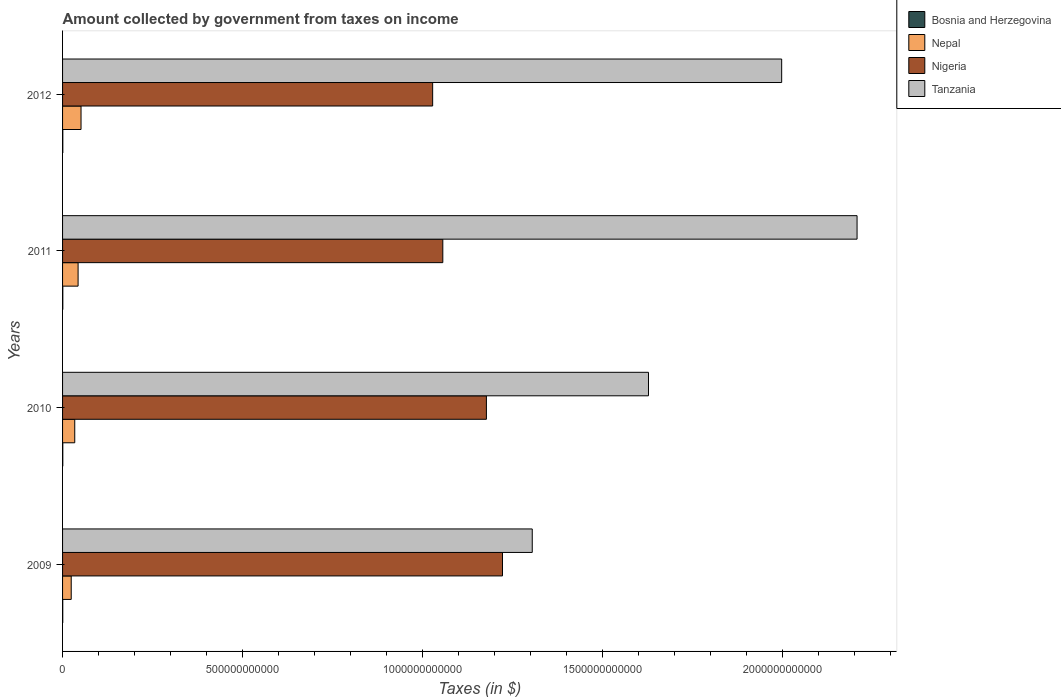Are the number of bars on each tick of the Y-axis equal?
Your answer should be very brief. Yes. How many bars are there on the 4th tick from the top?
Give a very brief answer. 4. In how many cases, is the number of bars for a given year not equal to the number of legend labels?
Offer a terse response. 0. What is the amount collected by government from taxes on income in Nigeria in 2012?
Provide a succinct answer. 1.03e+12. Across all years, what is the maximum amount collected by government from taxes on income in Nigeria?
Keep it short and to the point. 1.22e+12. Across all years, what is the minimum amount collected by government from taxes on income in Bosnia and Herzegovina?
Give a very brief answer. 4.93e+08. What is the total amount collected by government from taxes on income in Nigeria in the graph?
Your answer should be very brief. 4.48e+12. What is the difference between the amount collected by government from taxes on income in Bosnia and Herzegovina in 2010 and that in 2011?
Provide a succinct answer. -5.28e+07. What is the difference between the amount collected by government from taxes on income in Tanzania in 2010 and the amount collected by government from taxes on income in Nepal in 2009?
Offer a terse response. 1.60e+12. What is the average amount collected by government from taxes on income in Tanzania per year?
Offer a very short reply. 1.78e+12. In the year 2011, what is the difference between the amount collected by government from taxes on income in Bosnia and Herzegovina and amount collected by government from taxes on income in Nigeria?
Your response must be concise. -1.06e+12. What is the ratio of the amount collected by government from taxes on income in Tanzania in 2011 to that in 2012?
Give a very brief answer. 1.1. Is the difference between the amount collected by government from taxes on income in Bosnia and Herzegovina in 2010 and 2011 greater than the difference between the amount collected by government from taxes on income in Nigeria in 2010 and 2011?
Provide a short and direct response. No. What is the difference between the highest and the second highest amount collected by government from taxes on income in Nigeria?
Offer a very short reply. 4.47e+1. What is the difference between the highest and the lowest amount collected by government from taxes on income in Bosnia and Herzegovina?
Make the answer very short. 2.05e+08. What does the 2nd bar from the top in 2011 represents?
Provide a short and direct response. Nigeria. What does the 2nd bar from the bottom in 2012 represents?
Make the answer very short. Nepal. What is the difference between two consecutive major ticks on the X-axis?
Make the answer very short. 5.00e+11. How are the legend labels stacked?
Offer a terse response. Vertical. What is the title of the graph?
Provide a short and direct response. Amount collected by government from taxes on income. What is the label or title of the X-axis?
Your answer should be very brief. Taxes (in $). What is the label or title of the Y-axis?
Give a very brief answer. Years. What is the Taxes (in $) of Bosnia and Herzegovina in 2009?
Provide a succinct answer. 4.93e+08. What is the Taxes (in $) of Nepal in 2009?
Your response must be concise. 2.41e+1. What is the Taxes (in $) in Nigeria in 2009?
Your answer should be compact. 1.22e+12. What is the Taxes (in $) in Tanzania in 2009?
Your answer should be compact. 1.30e+12. What is the Taxes (in $) of Bosnia and Herzegovina in 2010?
Offer a very short reply. 6.25e+08. What is the Taxes (in $) in Nepal in 2010?
Provide a succinct answer. 3.38e+1. What is the Taxes (in $) in Nigeria in 2010?
Your answer should be very brief. 1.18e+12. What is the Taxes (in $) of Tanzania in 2010?
Your answer should be very brief. 1.63e+12. What is the Taxes (in $) in Bosnia and Herzegovina in 2011?
Keep it short and to the point. 6.78e+08. What is the Taxes (in $) of Nepal in 2011?
Keep it short and to the point. 4.31e+1. What is the Taxes (in $) of Nigeria in 2011?
Keep it short and to the point. 1.06e+12. What is the Taxes (in $) of Tanzania in 2011?
Provide a succinct answer. 2.21e+12. What is the Taxes (in $) in Bosnia and Herzegovina in 2012?
Make the answer very short. 6.98e+08. What is the Taxes (in $) in Nepal in 2012?
Offer a very short reply. 5.13e+1. What is the Taxes (in $) in Nigeria in 2012?
Provide a succinct answer. 1.03e+12. What is the Taxes (in $) in Tanzania in 2012?
Your answer should be compact. 2.00e+12. Across all years, what is the maximum Taxes (in $) in Bosnia and Herzegovina?
Provide a succinct answer. 6.98e+08. Across all years, what is the maximum Taxes (in $) in Nepal?
Offer a terse response. 5.13e+1. Across all years, what is the maximum Taxes (in $) in Nigeria?
Provide a short and direct response. 1.22e+12. Across all years, what is the maximum Taxes (in $) of Tanzania?
Your response must be concise. 2.21e+12. Across all years, what is the minimum Taxes (in $) of Bosnia and Herzegovina?
Offer a terse response. 4.93e+08. Across all years, what is the minimum Taxes (in $) of Nepal?
Your answer should be very brief. 2.41e+1. Across all years, what is the minimum Taxes (in $) in Nigeria?
Ensure brevity in your answer.  1.03e+12. Across all years, what is the minimum Taxes (in $) in Tanzania?
Provide a succinct answer. 1.30e+12. What is the total Taxes (in $) in Bosnia and Herzegovina in the graph?
Your answer should be very brief. 2.50e+09. What is the total Taxes (in $) in Nepal in the graph?
Provide a succinct answer. 1.52e+11. What is the total Taxes (in $) of Nigeria in the graph?
Keep it short and to the point. 4.48e+12. What is the total Taxes (in $) of Tanzania in the graph?
Your response must be concise. 7.14e+12. What is the difference between the Taxes (in $) of Bosnia and Herzegovina in 2009 and that in 2010?
Make the answer very short. -1.32e+08. What is the difference between the Taxes (in $) of Nepal in 2009 and that in 2010?
Offer a very short reply. -9.77e+09. What is the difference between the Taxes (in $) in Nigeria in 2009 and that in 2010?
Offer a terse response. 4.47e+1. What is the difference between the Taxes (in $) of Tanzania in 2009 and that in 2010?
Ensure brevity in your answer.  -3.23e+11. What is the difference between the Taxes (in $) of Bosnia and Herzegovina in 2009 and that in 2011?
Your answer should be compact. -1.85e+08. What is the difference between the Taxes (in $) in Nepal in 2009 and that in 2011?
Provide a succinct answer. -1.91e+1. What is the difference between the Taxes (in $) of Nigeria in 2009 and that in 2011?
Your answer should be very brief. 1.66e+11. What is the difference between the Taxes (in $) of Tanzania in 2009 and that in 2011?
Your response must be concise. -9.02e+11. What is the difference between the Taxes (in $) of Bosnia and Herzegovina in 2009 and that in 2012?
Ensure brevity in your answer.  -2.05e+08. What is the difference between the Taxes (in $) of Nepal in 2009 and that in 2012?
Make the answer very short. -2.73e+1. What is the difference between the Taxes (in $) in Nigeria in 2009 and that in 2012?
Offer a very short reply. 1.94e+11. What is the difference between the Taxes (in $) in Tanzania in 2009 and that in 2012?
Offer a terse response. -6.93e+11. What is the difference between the Taxes (in $) in Bosnia and Herzegovina in 2010 and that in 2011?
Your response must be concise. -5.28e+07. What is the difference between the Taxes (in $) of Nepal in 2010 and that in 2011?
Your response must be concise. -9.30e+09. What is the difference between the Taxes (in $) of Nigeria in 2010 and that in 2011?
Make the answer very short. 1.21e+11. What is the difference between the Taxes (in $) in Tanzania in 2010 and that in 2011?
Give a very brief answer. -5.79e+11. What is the difference between the Taxes (in $) of Bosnia and Herzegovina in 2010 and that in 2012?
Your answer should be compact. -7.31e+07. What is the difference between the Taxes (in $) in Nepal in 2010 and that in 2012?
Ensure brevity in your answer.  -1.75e+1. What is the difference between the Taxes (in $) of Nigeria in 2010 and that in 2012?
Provide a succinct answer. 1.49e+11. What is the difference between the Taxes (in $) in Tanzania in 2010 and that in 2012?
Give a very brief answer. -3.70e+11. What is the difference between the Taxes (in $) in Bosnia and Herzegovina in 2011 and that in 2012?
Provide a short and direct response. -2.03e+07. What is the difference between the Taxes (in $) of Nepal in 2011 and that in 2012?
Keep it short and to the point. -8.18e+09. What is the difference between the Taxes (in $) in Nigeria in 2011 and that in 2012?
Offer a terse response. 2.82e+1. What is the difference between the Taxes (in $) in Tanzania in 2011 and that in 2012?
Offer a very short reply. 2.09e+11. What is the difference between the Taxes (in $) of Bosnia and Herzegovina in 2009 and the Taxes (in $) of Nepal in 2010?
Provide a short and direct response. -3.33e+1. What is the difference between the Taxes (in $) of Bosnia and Herzegovina in 2009 and the Taxes (in $) of Nigeria in 2010?
Give a very brief answer. -1.18e+12. What is the difference between the Taxes (in $) in Bosnia and Herzegovina in 2009 and the Taxes (in $) in Tanzania in 2010?
Ensure brevity in your answer.  -1.63e+12. What is the difference between the Taxes (in $) of Nepal in 2009 and the Taxes (in $) of Nigeria in 2010?
Offer a very short reply. -1.15e+12. What is the difference between the Taxes (in $) in Nepal in 2009 and the Taxes (in $) in Tanzania in 2010?
Keep it short and to the point. -1.60e+12. What is the difference between the Taxes (in $) of Nigeria in 2009 and the Taxes (in $) of Tanzania in 2010?
Your answer should be very brief. -4.05e+11. What is the difference between the Taxes (in $) of Bosnia and Herzegovina in 2009 and the Taxes (in $) of Nepal in 2011?
Provide a succinct answer. -4.26e+1. What is the difference between the Taxes (in $) of Bosnia and Herzegovina in 2009 and the Taxes (in $) of Nigeria in 2011?
Your answer should be compact. -1.06e+12. What is the difference between the Taxes (in $) in Bosnia and Herzegovina in 2009 and the Taxes (in $) in Tanzania in 2011?
Provide a short and direct response. -2.21e+12. What is the difference between the Taxes (in $) in Nepal in 2009 and the Taxes (in $) in Nigeria in 2011?
Keep it short and to the point. -1.03e+12. What is the difference between the Taxes (in $) of Nepal in 2009 and the Taxes (in $) of Tanzania in 2011?
Provide a succinct answer. -2.18e+12. What is the difference between the Taxes (in $) of Nigeria in 2009 and the Taxes (in $) of Tanzania in 2011?
Make the answer very short. -9.85e+11. What is the difference between the Taxes (in $) of Bosnia and Herzegovina in 2009 and the Taxes (in $) of Nepal in 2012?
Keep it short and to the point. -5.08e+1. What is the difference between the Taxes (in $) of Bosnia and Herzegovina in 2009 and the Taxes (in $) of Nigeria in 2012?
Your answer should be very brief. -1.03e+12. What is the difference between the Taxes (in $) of Bosnia and Herzegovina in 2009 and the Taxes (in $) of Tanzania in 2012?
Ensure brevity in your answer.  -2.00e+12. What is the difference between the Taxes (in $) in Nepal in 2009 and the Taxes (in $) in Nigeria in 2012?
Provide a short and direct response. -1.00e+12. What is the difference between the Taxes (in $) in Nepal in 2009 and the Taxes (in $) in Tanzania in 2012?
Provide a short and direct response. -1.97e+12. What is the difference between the Taxes (in $) of Nigeria in 2009 and the Taxes (in $) of Tanzania in 2012?
Make the answer very short. -7.75e+11. What is the difference between the Taxes (in $) in Bosnia and Herzegovina in 2010 and the Taxes (in $) in Nepal in 2011?
Your response must be concise. -4.25e+1. What is the difference between the Taxes (in $) in Bosnia and Herzegovina in 2010 and the Taxes (in $) in Nigeria in 2011?
Provide a succinct answer. -1.06e+12. What is the difference between the Taxes (in $) of Bosnia and Herzegovina in 2010 and the Taxes (in $) of Tanzania in 2011?
Ensure brevity in your answer.  -2.21e+12. What is the difference between the Taxes (in $) of Nepal in 2010 and the Taxes (in $) of Nigeria in 2011?
Keep it short and to the point. -1.02e+12. What is the difference between the Taxes (in $) of Nepal in 2010 and the Taxes (in $) of Tanzania in 2011?
Provide a short and direct response. -2.17e+12. What is the difference between the Taxes (in $) in Nigeria in 2010 and the Taxes (in $) in Tanzania in 2011?
Make the answer very short. -1.03e+12. What is the difference between the Taxes (in $) in Bosnia and Herzegovina in 2010 and the Taxes (in $) in Nepal in 2012?
Ensure brevity in your answer.  -5.07e+1. What is the difference between the Taxes (in $) of Bosnia and Herzegovina in 2010 and the Taxes (in $) of Nigeria in 2012?
Keep it short and to the point. -1.03e+12. What is the difference between the Taxes (in $) in Bosnia and Herzegovina in 2010 and the Taxes (in $) in Tanzania in 2012?
Make the answer very short. -2.00e+12. What is the difference between the Taxes (in $) of Nepal in 2010 and the Taxes (in $) of Nigeria in 2012?
Offer a terse response. -9.94e+11. What is the difference between the Taxes (in $) of Nepal in 2010 and the Taxes (in $) of Tanzania in 2012?
Provide a short and direct response. -1.96e+12. What is the difference between the Taxes (in $) in Nigeria in 2010 and the Taxes (in $) in Tanzania in 2012?
Offer a very short reply. -8.20e+11. What is the difference between the Taxes (in $) of Bosnia and Herzegovina in 2011 and the Taxes (in $) of Nepal in 2012?
Give a very brief answer. -5.06e+1. What is the difference between the Taxes (in $) in Bosnia and Herzegovina in 2011 and the Taxes (in $) in Nigeria in 2012?
Offer a terse response. -1.03e+12. What is the difference between the Taxes (in $) of Bosnia and Herzegovina in 2011 and the Taxes (in $) of Tanzania in 2012?
Your answer should be compact. -2.00e+12. What is the difference between the Taxes (in $) in Nepal in 2011 and the Taxes (in $) in Nigeria in 2012?
Your response must be concise. -9.85e+11. What is the difference between the Taxes (in $) of Nepal in 2011 and the Taxes (in $) of Tanzania in 2012?
Offer a terse response. -1.95e+12. What is the difference between the Taxes (in $) in Nigeria in 2011 and the Taxes (in $) in Tanzania in 2012?
Give a very brief answer. -9.41e+11. What is the average Taxes (in $) in Bosnia and Herzegovina per year?
Provide a short and direct response. 6.24e+08. What is the average Taxes (in $) in Nepal per year?
Your answer should be compact. 3.81e+1. What is the average Taxes (in $) of Nigeria per year?
Your answer should be compact. 1.12e+12. What is the average Taxes (in $) in Tanzania per year?
Keep it short and to the point. 1.78e+12. In the year 2009, what is the difference between the Taxes (in $) in Bosnia and Herzegovina and Taxes (in $) in Nepal?
Provide a short and direct response. -2.36e+1. In the year 2009, what is the difference between the Taxes (in $) in Bosnia and Herzegovina and Taxes (in $) in Nigeria?
Make the answer very short. -1.22e+12. In the year 2009, what is the difference between the Taxes (in $) in Bosnia and Herzegovina and Taxes (in $) in Tanzania?
Offer a very short reply. -1.30e+12. In the year 2009, what is the difference between the Taxes (in $) in Nepal and Taxes (in $) in Nigeria?
Your answer should be compact. -1.20e+12. In the year 2009, what is the difference between the Taxes (in $) of Nepal and Taxes (in $) of Tanzania?
Make the answer very short. -1.28e+12. In the year 2009, what is the difference between the Taxes (in $) of Nigeria and Taxes (in $) of Tanzania?
Ensure brevity in your answer.  -8.26e+1. In the year 2010, what is the difference between the Taxes (in $) of Bosnia and Herzegovina and Taxes (in $) of Nepal?
Your answer should be compact. -3.32e+1. In the year 2010, what is the difference between the Taxes (in $) in Bosnia and Herzegovina and Taxes (in $) in Nigeria?
Ensure brevity in your answer.  -1.18e+12. In the year 2010, what is the difference between the Taxes (in $) of Bosnia and Herzegovina and Taxes (in $) of Tanzania?
Your answer should be very brief. -1.63e+12. In the year 2010, what is the difference between the Taxes (in $) of Nepal and Taxes (in $) of Nigeria?
Ensure brevity in your answer.  -1.14e+12. In the year 2010, what is the difference between the Taxes (in $) of Nepal and Taxes (in $) of Tanzania?
Your answer should be compact. -1.59e+12. In the year 2010, what is the difference between the Taxes (in $) in Nigeria and Taxes (in $) in Tanzania?
Your response must be concise. -4.50e+11. In the year 2011, what is the difference between the Taxes (in $) of Bosnia and Herzegovina and Taxes (in $) of Nepal?
Provide a short and direct response. -4.24e+1. In the year 2011, what is the difference between the Taxes (in $) of Bosnia and Herzegovina and Taxes (in $) of Nigeria?
Offer a terse response. -1.06e+12. In the year 2011, what is the difference between the Taxes (in $) in Bosnia and Herzegovina and Taxes (in $) in Tanzania?
Keep it short and to the point. -2.21e+12. In the year 2011, what is the difference between the Taxes (in $) of Nepal and Taxes (in $) of Nigeria?
Your response must be concise. -1.01e+12. In the year 2011, what is the difference between the Taxes (in $) in Nepal and Taxes (in $) in Tanzania?
Offer a very short reply. -2.16e+12. In the year 2011, what is the difference between the Taxes (in $) in Nigeria and Taxes (in $) in Tanzania?
Ensure brevity in your answer.  -1.15e+12. In the year 2012, what is the difference between the Taxes (in $) in Bosnia and Herzegovina and Taxes (in $) in Nepal?
Provide a succinct answer. -5.06e+1. In the year 2012, what is the difference between the Taxes (in $) in Bosnia and Herzegovina and Taxes (in $) in Nigeria?
Your answer should be compact. -1.03e+12. In the year 2012, what is the difference between the Taxes (in $) of Bosnia and Herzegovina and Taxes (in $) of Tanzania?
Ensure brevity in your answer.  -2.00e+12. In the year 2012, what is the difference between the Taxes (in $) of Nepal and Taxes (in $) of Nigeria?
Provide a succinct answer. -9.77e+11. In the year 2012, what is the difference between the Taxes (in $) in Nepal and Taxes (in $) in Tanzania?
Ensure brevity in your answer.  -1.95e+12. In the year 2012, what is the difference between the Taxes (in $) in Nigeria and Taxes (in $) in Tanzania?
Your response must be concise. -9.69e+11. What is the ratio of the Taxes (in $) in Bosnia and Herzegovina in 2009 to that in 2010?
Provide a short and direct response. 0.79. What is the ratio of the Taxes (in $) in Nepal in 2009 to that in 2010?
Your answer should be compact. 0.71. What is the ratio of the Taxes (in $) in Nigeria in 2009 to that in 2010?
Your answer should be very brief. 1.04. What is the ratio of the Taxes (in $) in Tanzania in 2009 to that in 2010?
Make the answer very short. 0.8. What is the ratio of the Taxes (in $) of Bosnia and Herzegovina in 2009 to that in 2011?
Ensure brevity in your answer.  0.73. What is the ratio of the Taxes (in $) of Nepal in 2009 to that in 2011?
Your response must be concise. 0.56. What is the ratio of the Taxes (in $) in Nigeria in 2009 to that in 2011?
Your answer should be compact. 1.16. What is the ratio of the Taxes (in $) in Tanzania in 2009 to that in 2011?
Ensure brevity in your answer.  0.59. What is the ratio of the Taxes (in $) of Bosnia and Herzegovina in 2009 to that in 2012?
Your response must be concise. 0.71. What is the ratio of the Taxes (in $) of Nepal in 2009 to that in 2012?
Provide a succinct answer. 0.47. What is the ratio of the Taxes (in $) in Nigeria in 2009 to that in 2012?
Make the answer very short. 1.19. What is the ratio of the Taxes (in $) in Tanzania in 2009 to that in 2012?
Your answer should be compact. 0.65. What is the ratio of the Taxes (in $) in Bosnia and Herzegovina in 2010 to that in 2011?
Make the answer very short. 0.92. What is the ratio of the Taxes (in $) of Nepal in 2010 to that in 2011?
Give a very brief answer. 0.78. What is the ratio of the Taxes (in $) in Nigeria in 2010 to that in 2011?
Your answer should be compact. 1.11. What is the ratio of the Taxes (in $) of Tanzania in 2010 to that in 2011?
Your answer should be very brief. 0.74. What is the ratio of the Taxes (in $) of Bosnia and Herzegovina in 2010 to that in 2012?
Your answer should be compact. 0.9. What is the ratio of the Taxes (in $) in Nepal in 2010 to that in 2012?
Provide a short and direct response. 0.66. What is the ratio of the Taxes (in $) of Nigeria in 2010 to that in 2012?
Your answer should be compact. 1.15. What is the ratio of the Taxes (in $) in Tanzania in 2010 to that in 2012?
Give a very brief answer. 0.81. What is the ratio of the Taxes (in $) in Bosnia and Herzegovina in 2011 to that in 2012?
Provide a succinct answer. 0.97. What is the ratio of the Taxes (in $) in Nepal in 2011 to that in 2012?
Keep it short and to the point. 0.84. What is the ratio of the Taxes (in $) in Nigeria in 2011 to that in 2012?
Your answer should be compact. 1.03. What is the ratio of the Taxes (in $) in Tanzania in 2011 to that in 2012?
Your answer should be compact. 1.1. What is the difference between the highest and the second highest Taxes (in $) of Bosnia and Herzegovina?
Your answer should be very brief. 2.03e+07. What is the difference between the highest and the second highest Taxes (in $) in Nepal?
Give a very brief answer. 8.18e+09. What is the difference between the highest and the second highest Taxes (in $) in Nigeria?
Offer a terse response. 4.47e+1. What is the difference between the highest and the second highest Taxes (in $) in Tanzania?
Offer a terse response. 2.09e+11. What is the difference between the highest and the lowest Taxes (in $) in Bosnia and Herzegovina?
Your answer should be very brief. 2.05e+08. What is the difference between the highest and the lowest Taxes (in $) in Nepal?
Your answer should be compact. 2.73e+1. What is the difference between the highest and the lowest Taxes (in $) of Nigeria?
Offer a very short reply. 1.94e+11. What is the difference between the highest and the lowest Taxes (in $) of Tanzania?
Ensure brevity in your answer.  9.02e+11. 